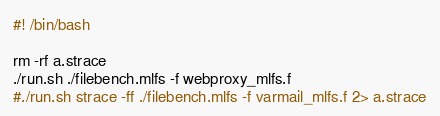<code> <loc_0><loc_0><loc_500><loc_500><_Bash_>#! /bin/bash

rm -rf a.strace
./run.sh ./filebench.mlfs -f webproxy_mlfs.f
#./run.sh strace -ff ./filebench.mlfs -f varmail_mlfs.f 2> a.strace
</code> 